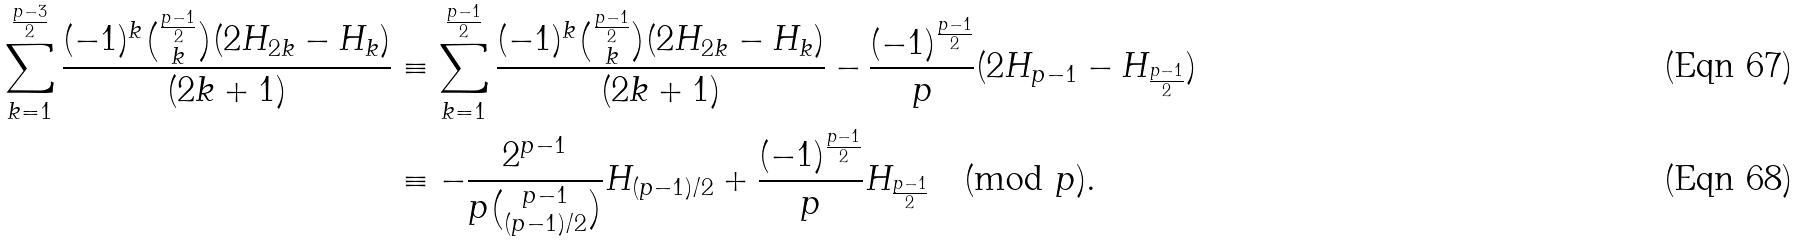Convert formula to latex. <formula><loc_0><loc_0><loc_500><loc_500>\sum _ { k = 1 } ^ { \frac { p - 3 } 2 } \frac { ( - 1 ) ^ { k } \binom { \frac { p - 1 } 2 } k ( 2 H _ { 2 k } - H _ { k } ) } { ( 2 k + 1 ) } & \equiv \sum _ { k = 1 } ^ { \frac { p - 1 } 2 } \frac { ( - 1 ) ^ { k } \binom { \frac { p - 1 } 2 } k ( 2 H _ { 2 k } - H _ { k } ) } { ( 2 k + 1 ) } - \frac { ( - 1 ) ^ { \frac { p - 1 } 2 } } { p } ( 2 H _ { p - 1 } - H _ { \frac { p - 1 } 2 } ) \\ & \equiv - \frac { 2 ^ { p - 1 } } { p \binom { p - 1 } { ( p - 1 ) / 2 } } H _ { ( p - 1 ) / 2 } + \frac { ( - 1 ) ^ { \frac { p - 1 } 2 } } { p } H _ { \frac { p - 1 } 2 } \pmod { p } .</formula> 